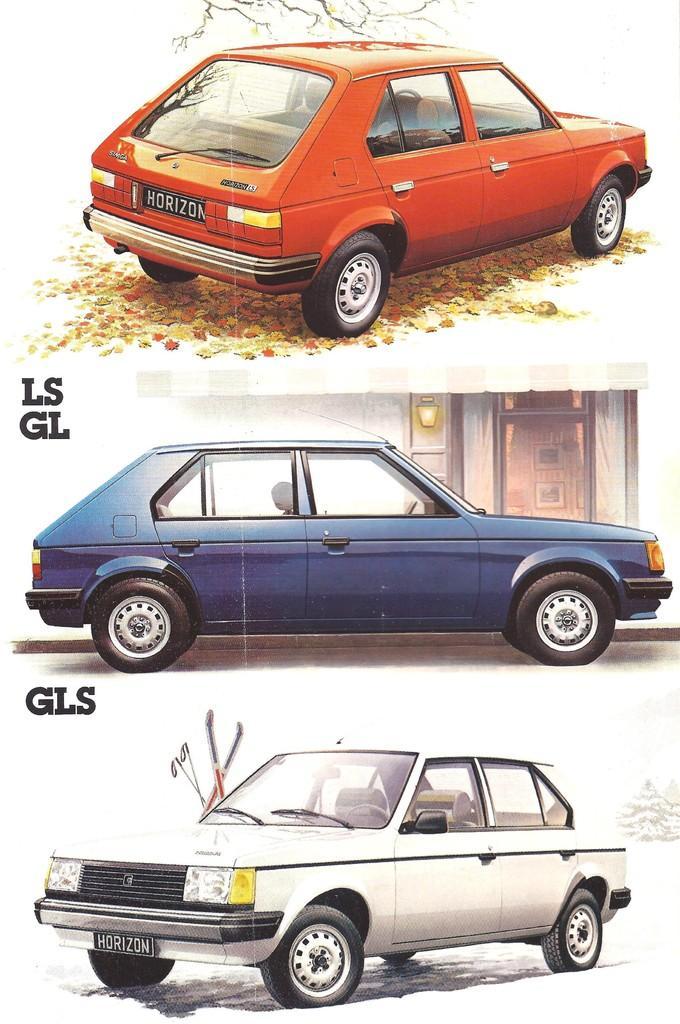Can you describe this image briefly? In this picture we can see the college of three images. At the top there is a red color car parked on the ground and there are some objects lying on the ground. In the center there is a blue color car parked on the ground. In the background we can see the door of a building and wall mounted lamp. At the bottom there is a white color car parked on the ground and there are some sticks and we can see the text on the image. 